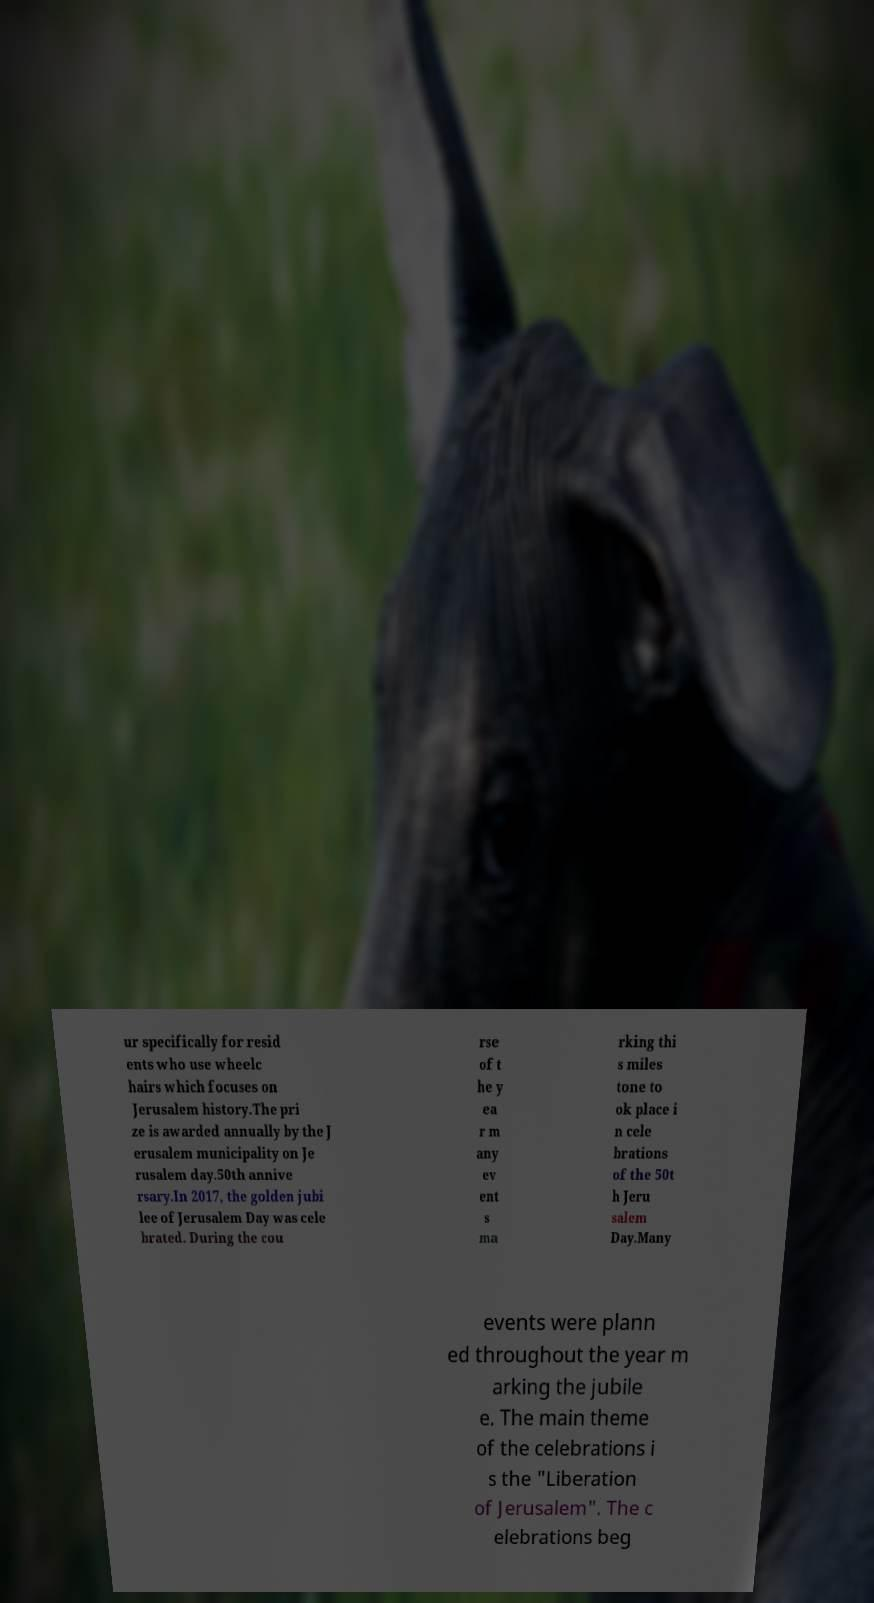For documentation purposes, I need the text within this image transcribed. Could you provide that? ur specifically for resid ents who use wheelc hairs which focuses on Jerusalem history.The pri ze is awarded annually by the J erusalem municipality on Je rusalem day.50th annive rsary.In 2017, the golden jubi lee of Jerusalem Day was cele brated. During the cou rse of t he y ea r m any ev ent s ma rking thi s miles tone to ok place i n cele brations of the 50t h Jeru salem Day.Many events were plann ed throughout the year m arking the jubile e. The main theme of the celebrations i s the "Liberation of Jerusalem". The c elebrations beg 